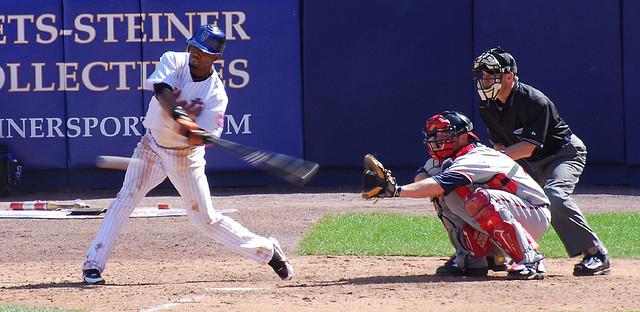Why is there a man behind the catcher?
Answer briefly. Umpire. Is the catcher ready?
Answer briefly. Yes. What team does the batter play for?
Write a very short answer. Mets. 